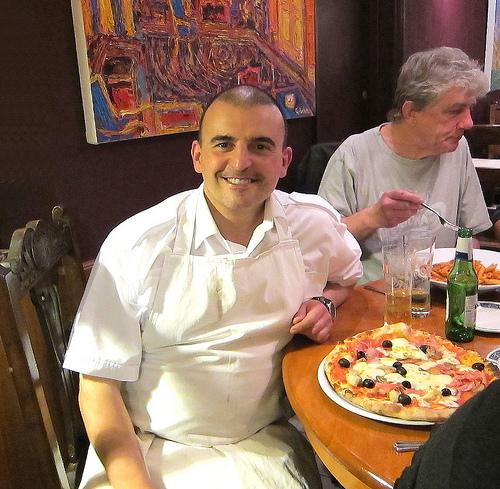Question: who is in the picture?
Choices:
A. Two people.
B. Two men.
C. Two children.
D. A group of men.
Answer with the letter. Answer: B Question: who is smiling?
Choices:
A. The woman in blue.
B. The children.
C. The man who just got paid.
D. The man on the left.
Answer with the letter. Answer: D Question: what is the right man doing?
Choices:
A. Eating.
B. Sleeping.
C. Brushing his teeth.
D. Watching tv.
Answer with the letter. Answer: A Question: what are the men drinking?
Choices:
A. Water.
B. A coke.
C. Coffee.
D. Beer.
Answer with the letter. Answer: D Question: what color is the left man's apron?
Choices:
A. Black.
B. Grey.
C. Orange.
D. White.
Answer with the letter. Answer: D 